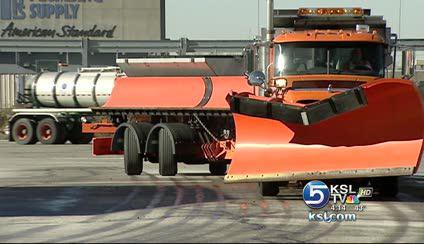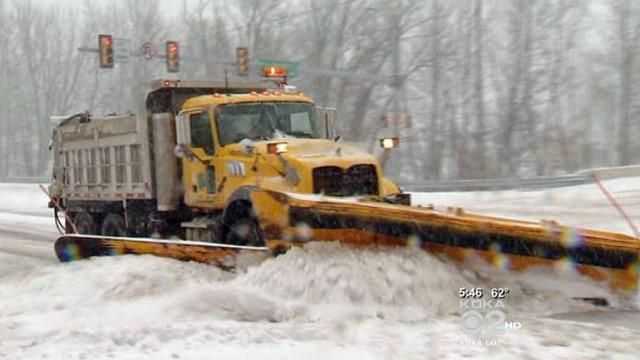The first image is the image on the left, the second image is the image on the right. Evaluate the accuracy of this statement regarding the images: "Exactly one snow plow is plowing snow.". Is it true? Answer yes or no. Yes. The first image is the image on the left, the second image is the image on the right. Given the left and right images, does the statement "The road in the image on the left is cleared of snow, while the snow is still being cleared in the image on the right." hold true? Answer yes or no. Yes. 